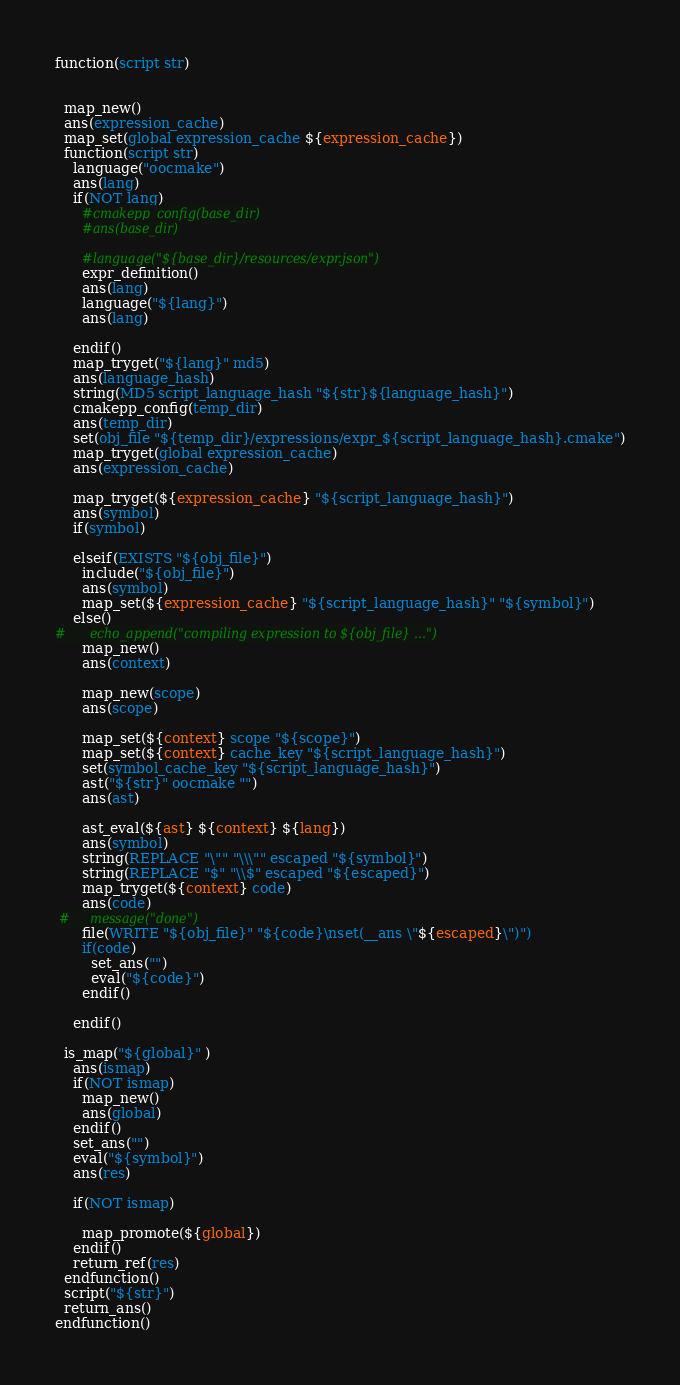Convert code to text. <code><loc_0><loc_0><loc_500><loc_500><_CMake_>function(script str)


  map_new()
  ans(expression_cache)
  map_set(global expression_cache ${expression_cache})
  function(script str)
    language("oocmake")
    ans(lang)
    if(NOT lang)
      #cmakepp_config(base_dir)
      #ans(base_dir)

      #language("${base_dir}/resources/expr.json")
      expr_definition()
      ans(lang)
      language("${lang}")
      ans(lang)

    endif()
    map_tryget("${lang}" md5)
    ans(language_hash)
    string(MD5 script_language_hash "${str}${language_hash}")  
    cmakepp_config(temp_dir)
    ans(temp_dir)
    set(obj_file "${temp_dir}/expressions/expr_${script_language_hash}.cmake")
    map_tryget(global expression_cache)
    ans(expression_cache)

    map_tryget(${expression_cache} "${script_language_hash}")
    ans(symbol)
    if(symbol)

    elseif(EXISTS "${obj_file}")
      include("${obj_file}")
      ans(symbol)
      map_set(${expression_cache} "${script_language_hash}" "${symbol}")
    else()
#      echo_append("compiling expression to ${obj_file} ...")
      map_new()
      ans(context)

      map_new(scope)
      ans(scope)

      map_set(${context} scope "${scope}")
      map_set(${context} cache_key "${script_language_hash}")
      set(symbol_cache_key "${script_language_hash}")
      ast("${str}" oocmake "")
      ans(ast)

      ast_eval(${ast} ${context} ${lang})
      ans(symbol)
      string(REPLACE "\"" "\\\"" escaped "${symbol}")
      string(REPLACE "$" "\\$" escaped "${escaped}")
      map_tryget(${context} code)
      ans(code)
 #     message("done")
      file(WRITE "${obj_file}" "${code}\nset(__ans \"${escaped}\")")
      if(code)
        set_ans("")
        eval("${code}")
      endif()

    endif()

  is_map("${global}" )
    ans(ismap)
    if(NOT ismap)
      map_new()
      ans(global)
    endif()
    set_ans("")
    eval("${symbol}")
    ans(res)

    if(NOT ismap)

      map_promote(${global})
    endif()
    return_ref(res)
  endfunction()
  script("${str}")
  return_ans()
endfunction()</code> 